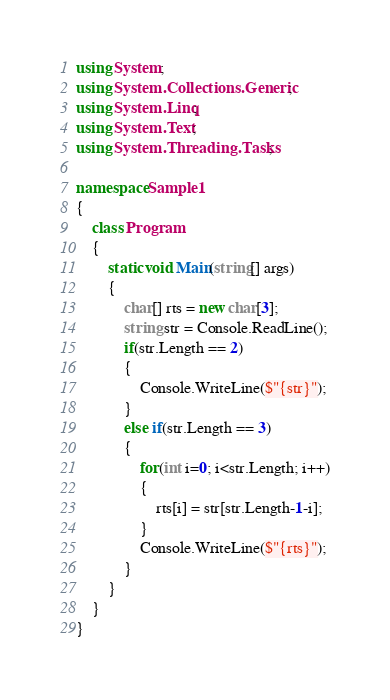Convert code to text. <code><loc_0><loc_0><loc_500><loc_500><_C#_>using System;
using System.Collections.Generic;
using System.Linq;
using System.Text;
using System.Threading.Tasks;

namespace Sample1
{
    class Program
    {
        static void Main(string[] args)
        {
            char[] rts = new char[3];
            string str = Console.ReadLine();
            if(str.Length == 2)
            {
                Console.WriteLine($"{str}");
            }
            else if(str.Length == 3)
            {
                for(int i=0; i<str.Length; i++)
                {
                    rts[i] = str[str.Length-1-i];
                }
                Console.WriteLine($"{rts}");
            }
        }
    }
}
</code> 